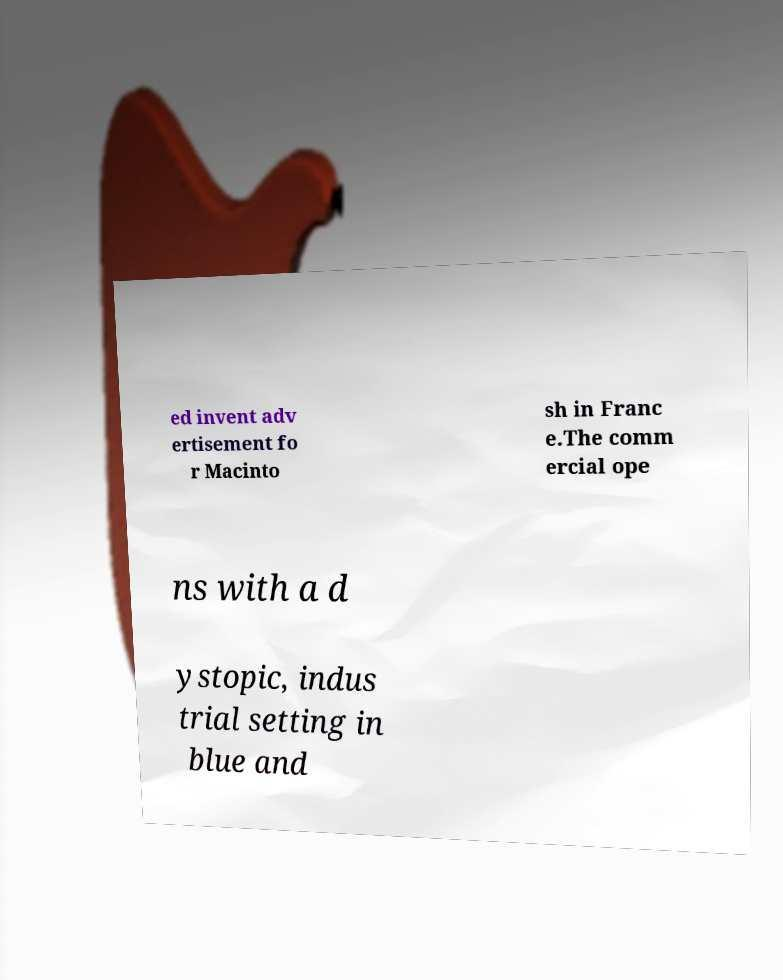Could you extract and type out the text from this image? ed invent adv ertisement fo r Macinto sh in Franc e.The comm ercial ope ns with a d ystopic, indus trial setting in blue and 